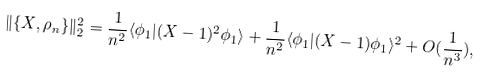<formula> <loc_0><loc_0><loc_500><loc_500>\| \{ X , \rho _ { n } \} \| _ { 2 } ^ { 2 } = \frac { 1 } { n ^ { 2 } } \langle \phi _ { 1 } | ( X - 1 ) ^ { 2 } \phi _ { 1 } \rangle + \frac { 1 } { n ^ { 2 } } \langle \phi _ { 1 } | ( X - 1 ) \phi _ { 1 } \rangle ^ { 2 } + O ( \frac { 1 } { n ^ { 3 } } ) ,</formula> 